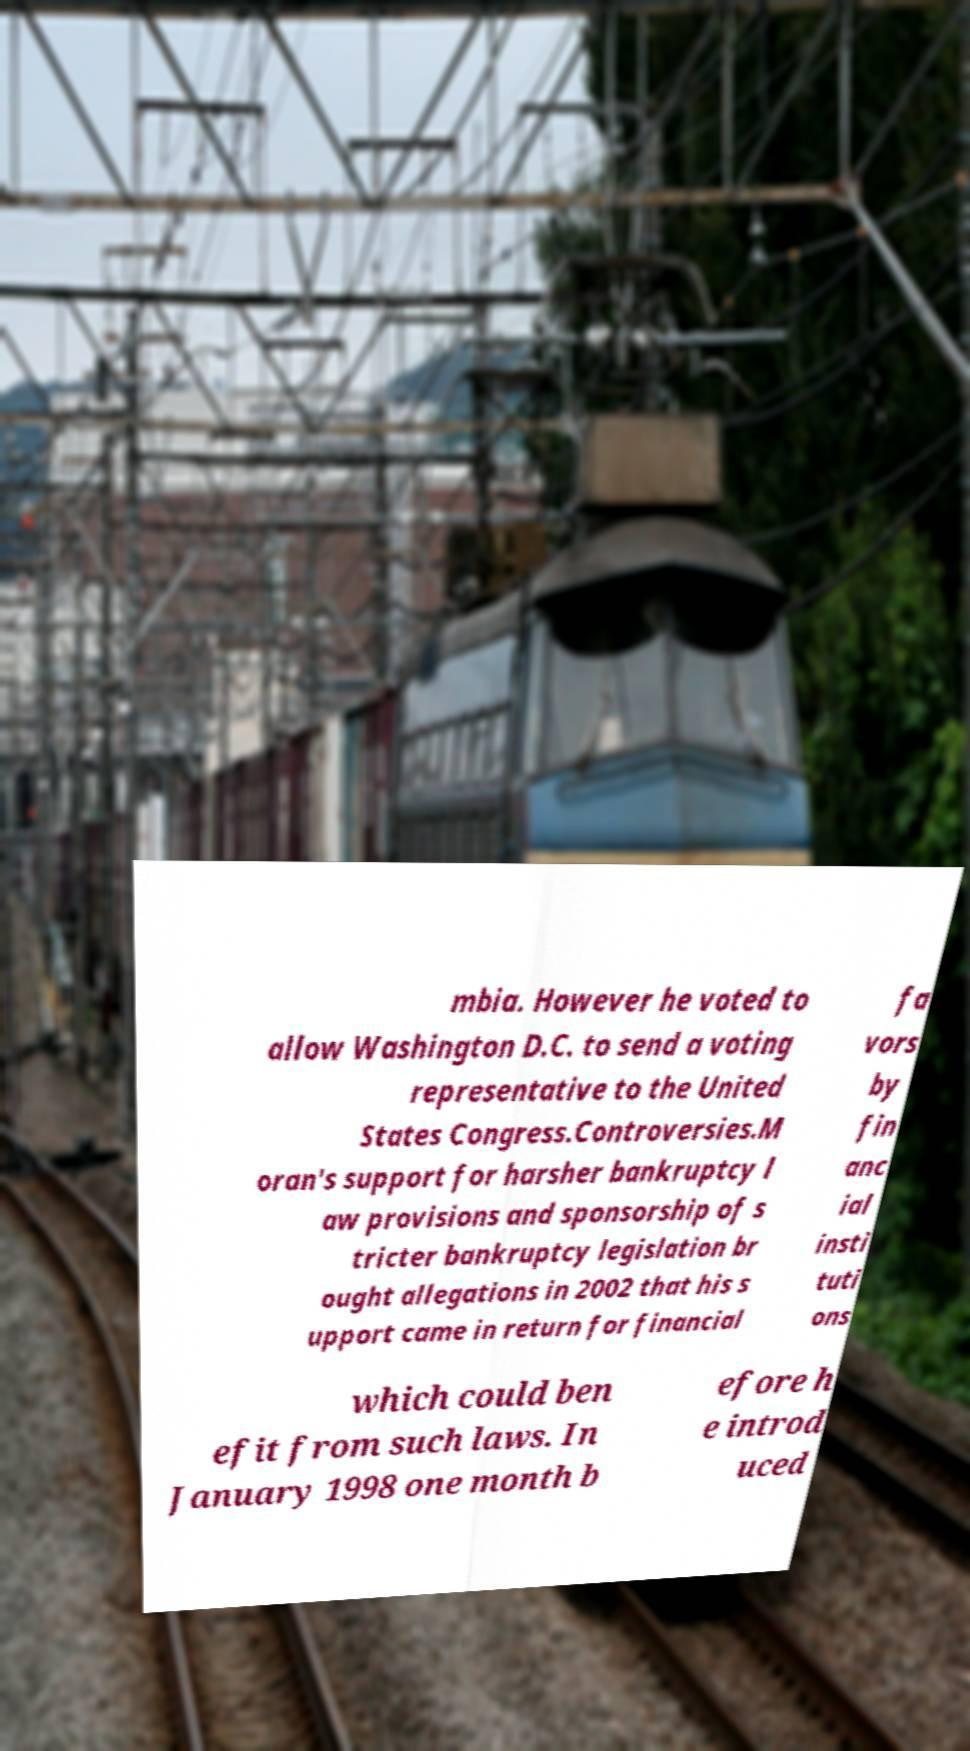Can you read and provide the text displayed in the image?This photo seems to have some interesting text. Can you extract and type it out for me? mbia. However he voted to allow Washington D.C. to send a voting representative to the United States Congress.Controversies.M oran's support for harsher bankruptcy l aw provisions and sponsorship of s tricter bankruptcy legislation br ought allegations in 2002 that his s upport came in return for financial fa vors by fin anc ial insti tuti ons which could ben efit from such laws. In January 1998 one month b efore h e introd uced 